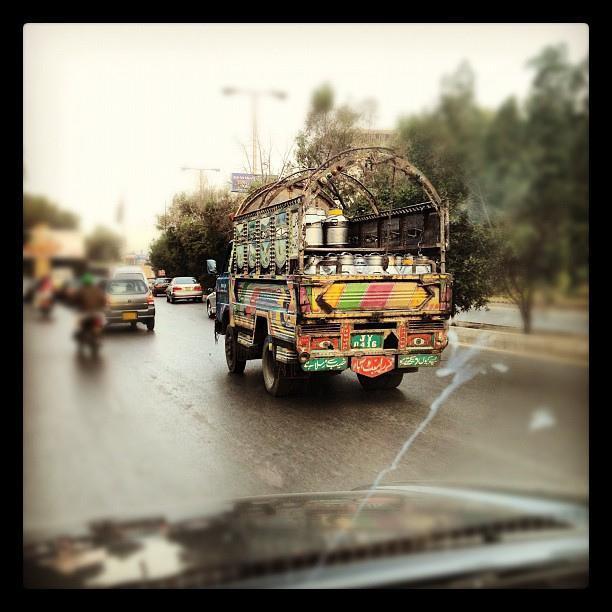How many giraffes are reaching for the branch?
Give a very brief answer. 0. 